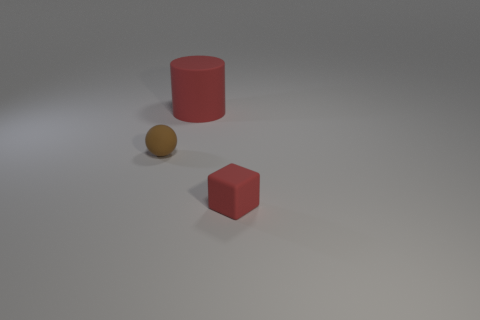Add 2 cyan cylinders. How many objects exist? 5 Subtract all cubes. How many objects are left? 2 Subtract 1 balls. How many balls are left? 0 Subtract all yellow balls. Subtract all green cubes. How many balls are left? 1 Subtract all red blocks. How many blue cylinders are left? 0 Subtract 0 purple spheres. How many objects are left? 3 Subtract all red blocks. Subtract all small spheres. How many objects are left? 1 Add 2 tiny red things. How many tiny red things are left? 3 Add 3 small red things. How many small red things exist? 4 